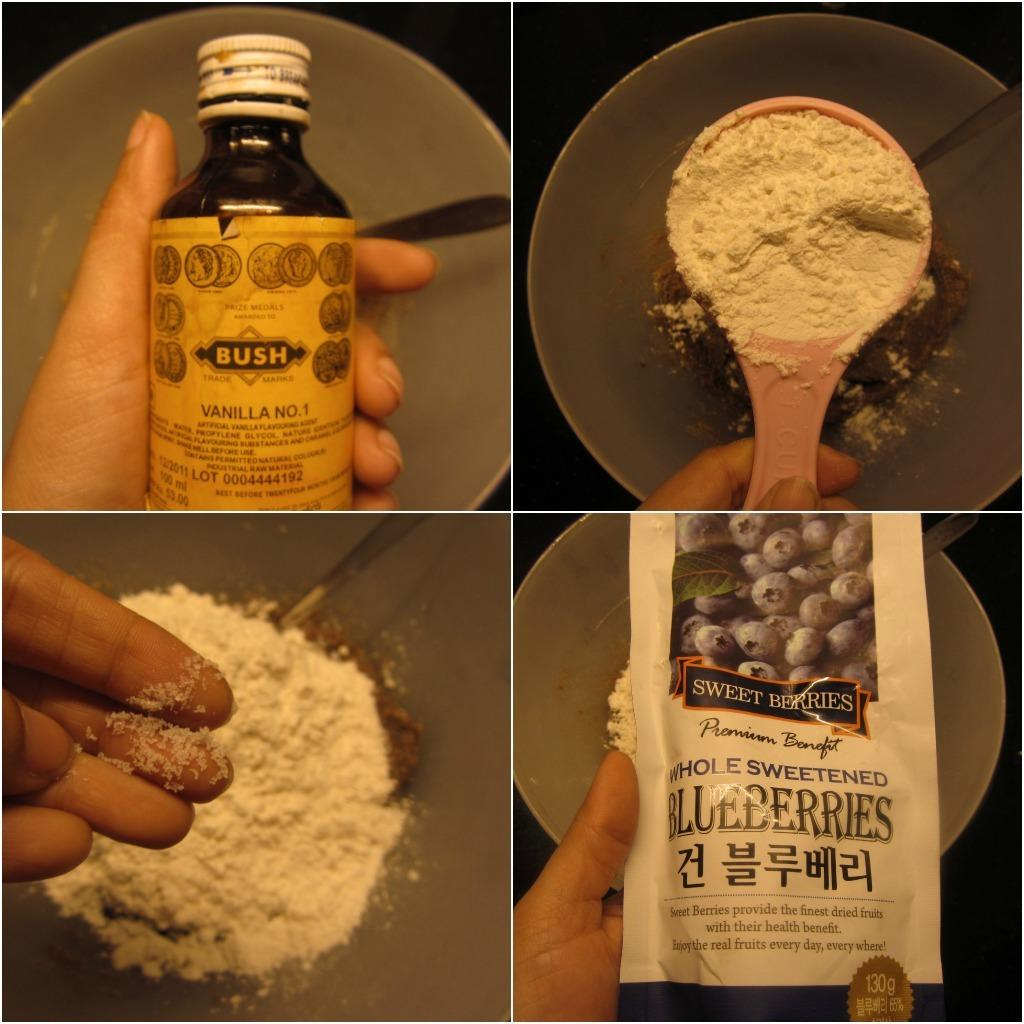<image>
Give a short and clear explanation of the subsequent image. Vanilla and Blueberries are shown on the front of these containers. 